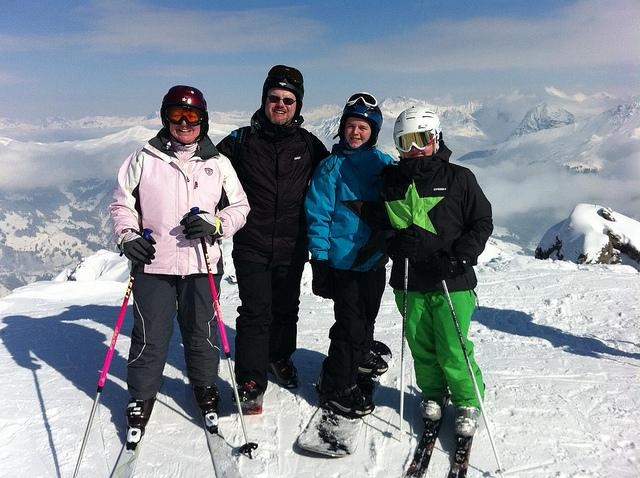What is a country that is famously a host to this sport? switzerland 